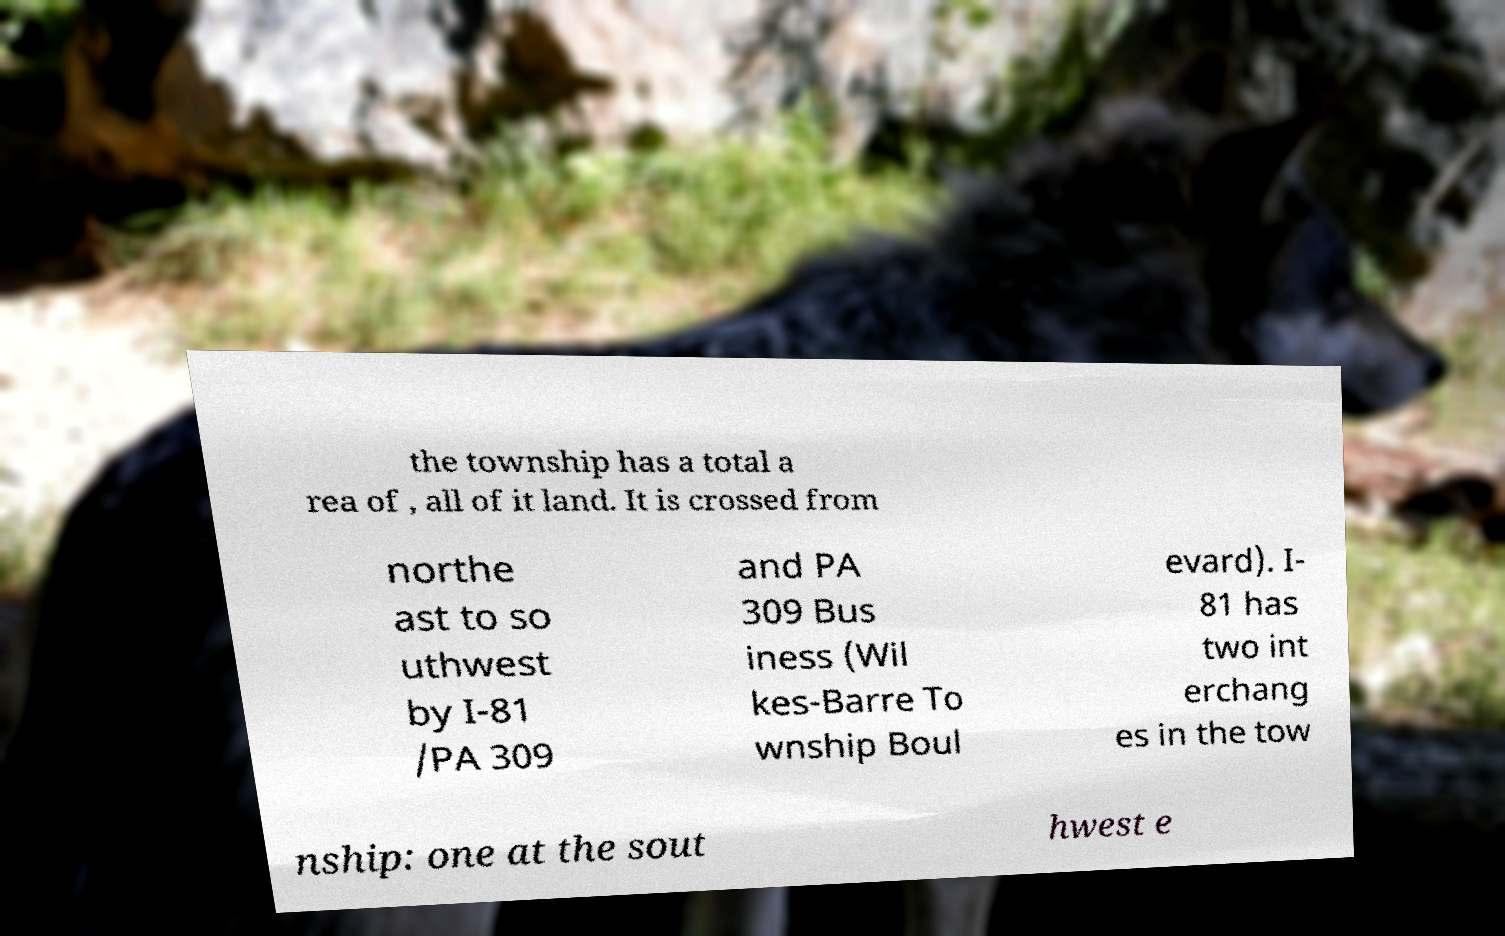There's text embedded in this image that I need extracted. Can you transcribe it verbatim? the township has a total a rea of , all of it land. It is crossed from northe ast to so uthwest by I-81 /PA 309 and PA 309 Bus iness (Wil kes-Barre To wnship Boul evard). I- 81 has two int erchang es in the tow nship: one at the sout hwest e 